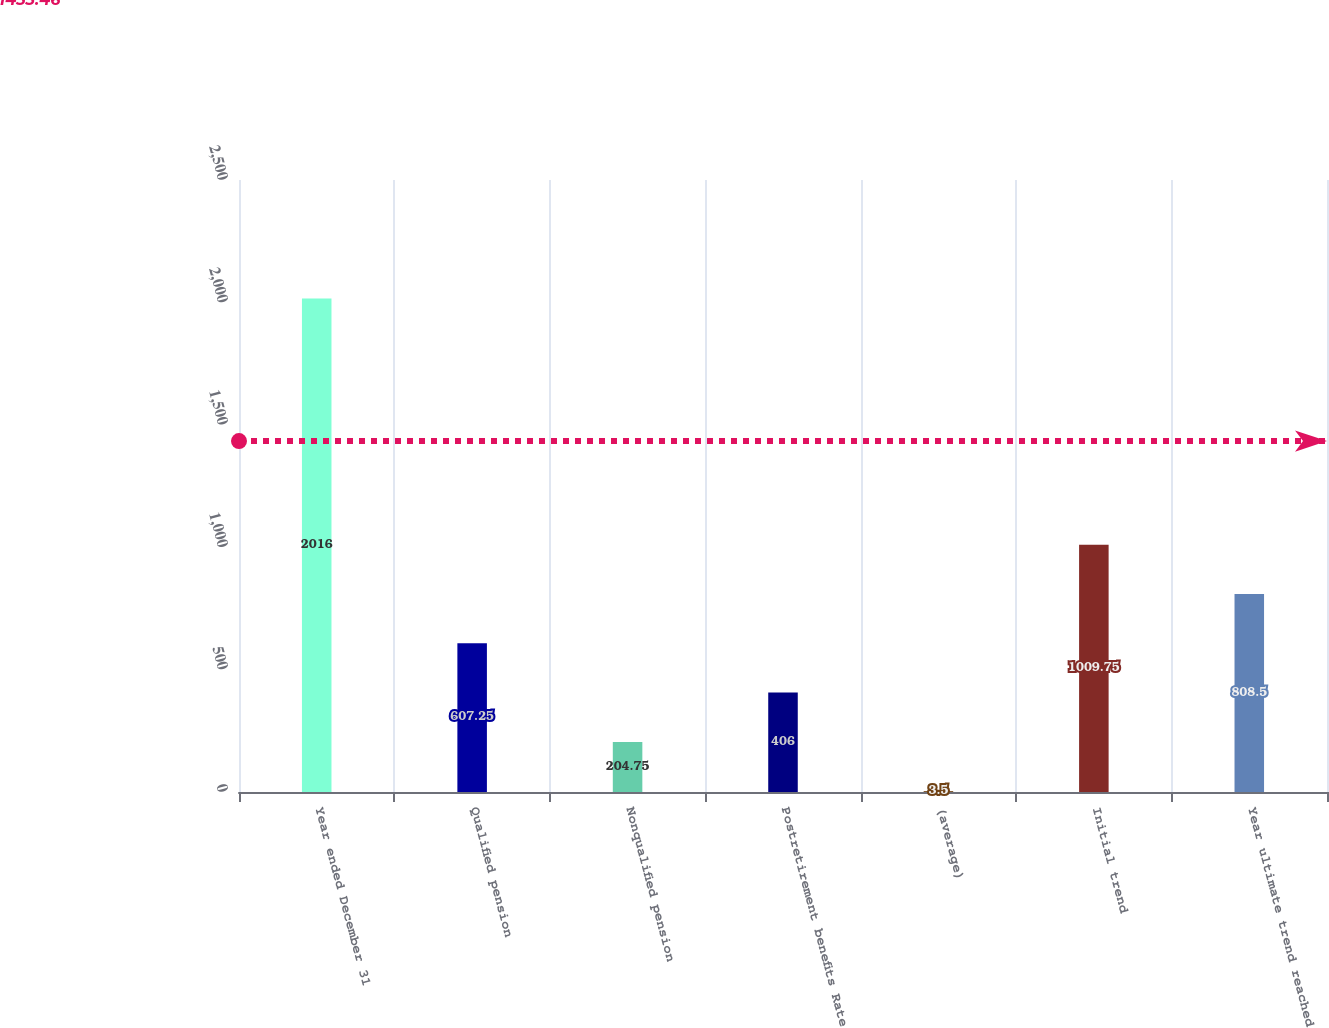Convert chart. <chart><loc_0><loc_0><loc_500><loc_500><bar_chart><fcel>Year ended December 31<fcel>Qualified pension<fcel>Nonqualified pension<fcel>Postretirement benefits Rate<fcel>(average)<fcel>Initial trend<fcel>Year ultimate trend reached<nl><fcel>2016<fcel>607.25<fcel>204.75<fcel>406<fcel>3.5<fcel>1009.75<fcel>808.5<nl></chart> 